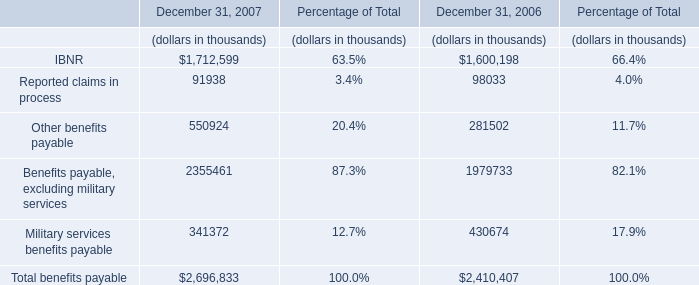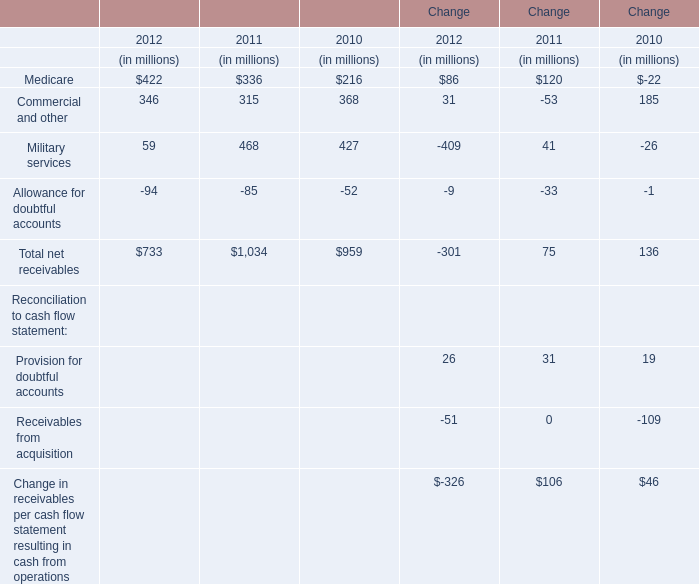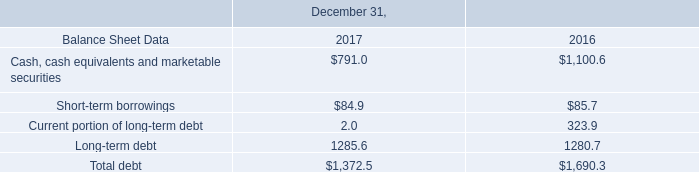what is the outstanding number of shares as of december 31 , 2017? 
Computations: (((320.0 - 1000000) / 4) / 0.21)
Answer: -1190095.2381. 